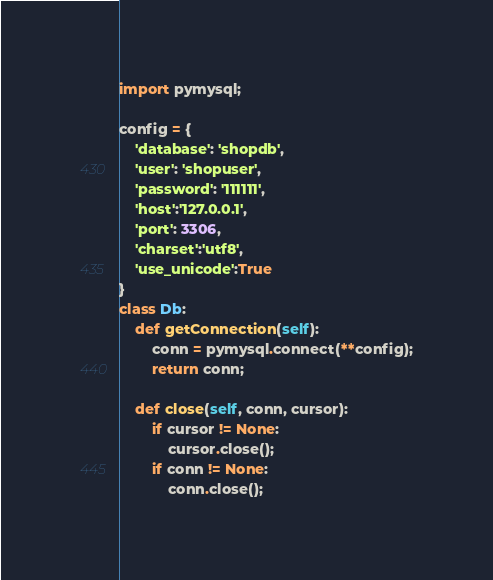<code> <loc_0><loc_0><loc_500><loc_500><_Python_>import pymysql;

config = {
    'database': 'shopdb',
    'user': 'shopuser',
    'password': '111111',
    'host':'127.0.0.1',
    'port': 3306,
    'charset':'utf8',
    'use_unicode':True
}
class Db:
    def getConnection(self):
        conn = pymysql.connect(**config);
        return conn;

    def close(self, conn, cursor):
        if cursor != None:
            cursor.close();
        if conn != None:
            conn.close();</code> 